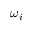Convert formula to latex. <formula><loc_0><loc_0><loc_500><loc_500>\omega _ { i }</formula> 